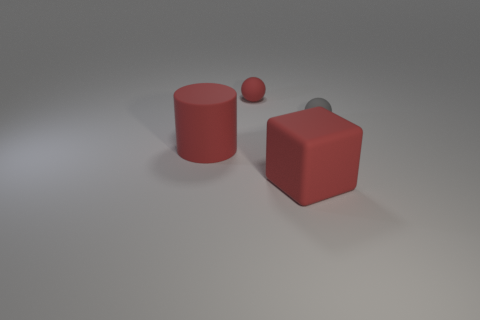What number of balls are red things or big red things?
Your answer should be very brief. 1. What material is the large thing that is the same color as the rubber block?
Offer a very short reply. Rubber. What number of tiny red things have the same shape as the gray rubber object?
Your answer should be very brief. 1. Are there more gray things right of the big red rubber block than large matte cubes that are right of the gray ball?
Give a very brief answer. Yes. Is the color of the small matte object that is on the left side of the big red matte block the same as the large cube?
Provide a succinct answer. Yes. The red matte block is what size?
Offer a very short reply. Large. There is a gray thing that is the same size as the red rubber ball; what material is it?
Make the answer very short. Rubber. The matte object in front of the big red matte cylinder is what color?
Your answer should be compact. Red. How many matte cylinders are there?
Offer a terse response. 1. Are there any gray objects that are on the left side of the thing that is behind the tiny ball that is to the right of the large cube?
Give a very brief answer. No. 